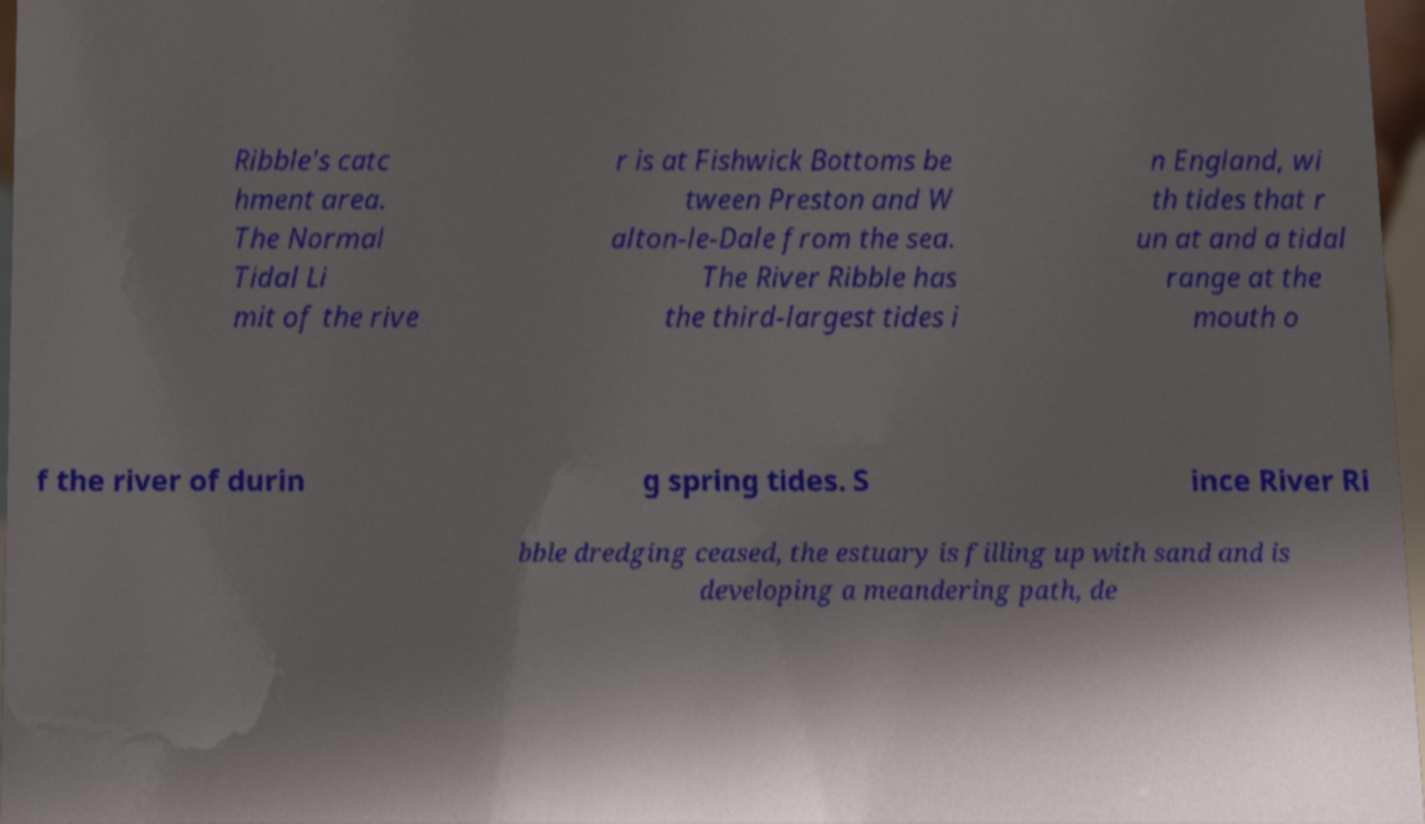For documentation purposes, I need the text within this image transcribed. Could you provide that? Ribble's catc hment area. The Normal Tidal Li mit of the rive r is at Fishwick Bottoms be tween Preston and W alton-le-Dale from the sea. The River Ribble has the third-largest tides i n England, wi th tides that r un at and a tidal range at the mouth o f the river of durin g spring tides. S ince River Ri bble dredging ceased, the estuary is filling up with sand and is developing a meandering path, de 